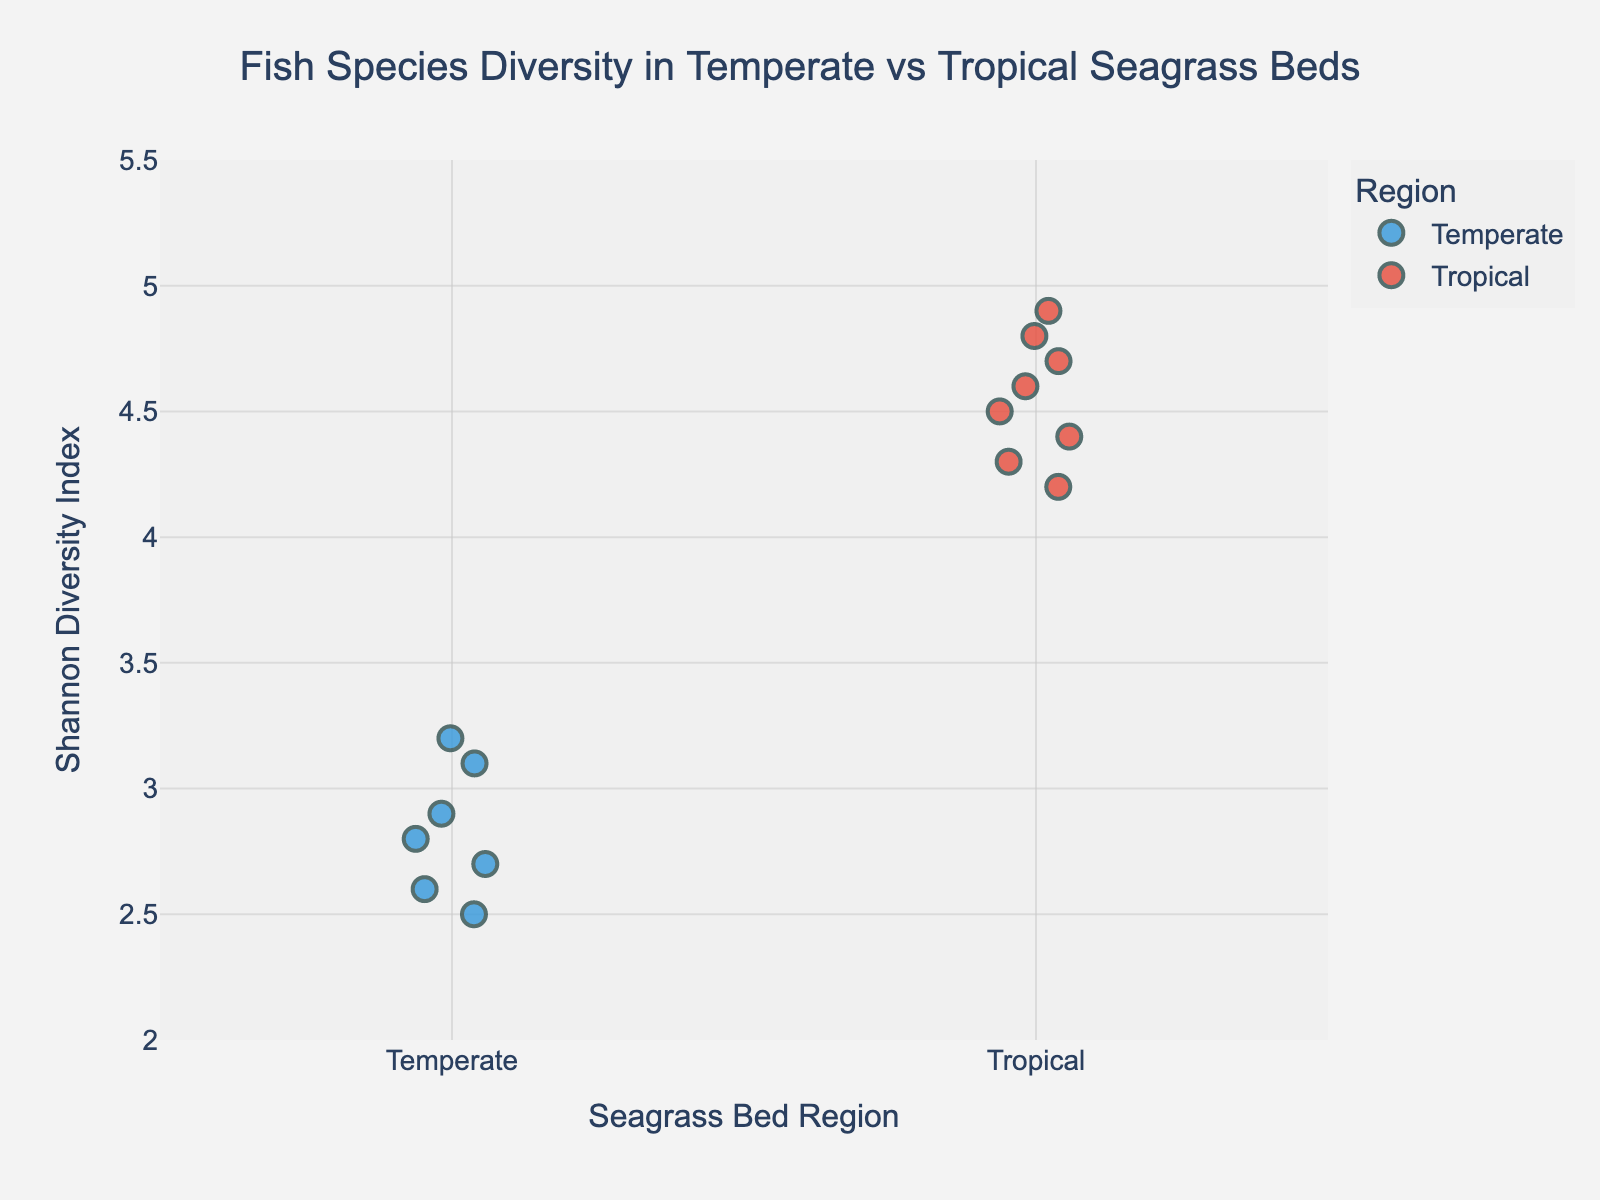What is the title of the figure? The title is displayed at the top of the plot and in larger font size than other texts on the figure.
Answer: Fish Species Diversity in Temperate vs Tropical Seagrass Beds How many fish species are represented in the 'Temperate' region? To determine the count, look for the number of points plotted under the 'Temperate' region along the x-axis.
Answer: 7 Which specific fish species has the highest Shannon Diversity Index in the 'Tropical' region? Find the point in the 'Tropical' region that is plotted the highest along the y-axis and hover over the point (if interactive) or refer to the corresponding label (if present).
Answer: Damselfish On average, which region has a higher Shannon Diversity Index? To find the average Shannon Diversity Index for both regions, calculate the mean of all values in each region. For 'Temperate’: (3.2 + 2.8 + 2.5 + 2.9 + 2.7 + 3.1 + 2.6) / 7 = 2.83. For 'Tropical': (4.5 + 4.2 + 4.8 + 4.6 + 4.3 + 4.7 + 4.4 + 4.9) / 8 = 4.55. Comparing the two, the 'Tropical' region has a higher average.
Answer: Tropical What is the median Shannon Diversity Index for fish species in the 'Tropical' region? Arrange the Shannon Diversity Index values of 'Tropical' region in ascending order (4.2, 4.3, 4.4, 4.5, 4.6, 4.7, 4.8, 4.9). The median is the middle value. As there are 8 values, the median is the average of the 4th and 5th values: (4.5 + 4.6) / 2 = 4.55.
Answer: 4.55 Is there more spread of values in the 'Temperate' or 'Tropical' region? The spread of values can be assessed by the range. For 'Temperate', the range is from a minimum of 2.5 to a maximum of 3.2 (3.2 - 2.5 = 0.7). For 'Tropical', the range is from a minimum of 4.2 to a maximum of 4.9 (4.9 - 4.2 = 0.7). Both regions have the same spread in visual appearance.
Answer: Equal What color represents the 'Temperate' region in the plot? Look at the legend on the plot. The 'Temperate' region is indicated by its corresponding color next to the label 'Temperate'.
Answer: Blue Which region shows a fish species with the lowest Shannon Diversity Index? Identify the lowest point on the y-axis in both regions. In the 'Temperate' region, the lowest is 2.5, whereas in the 'Tropical' region, the lowest is 4.2. Therefore, 'Temperate' shows the lowest diversity index.
Answer: Temperate 